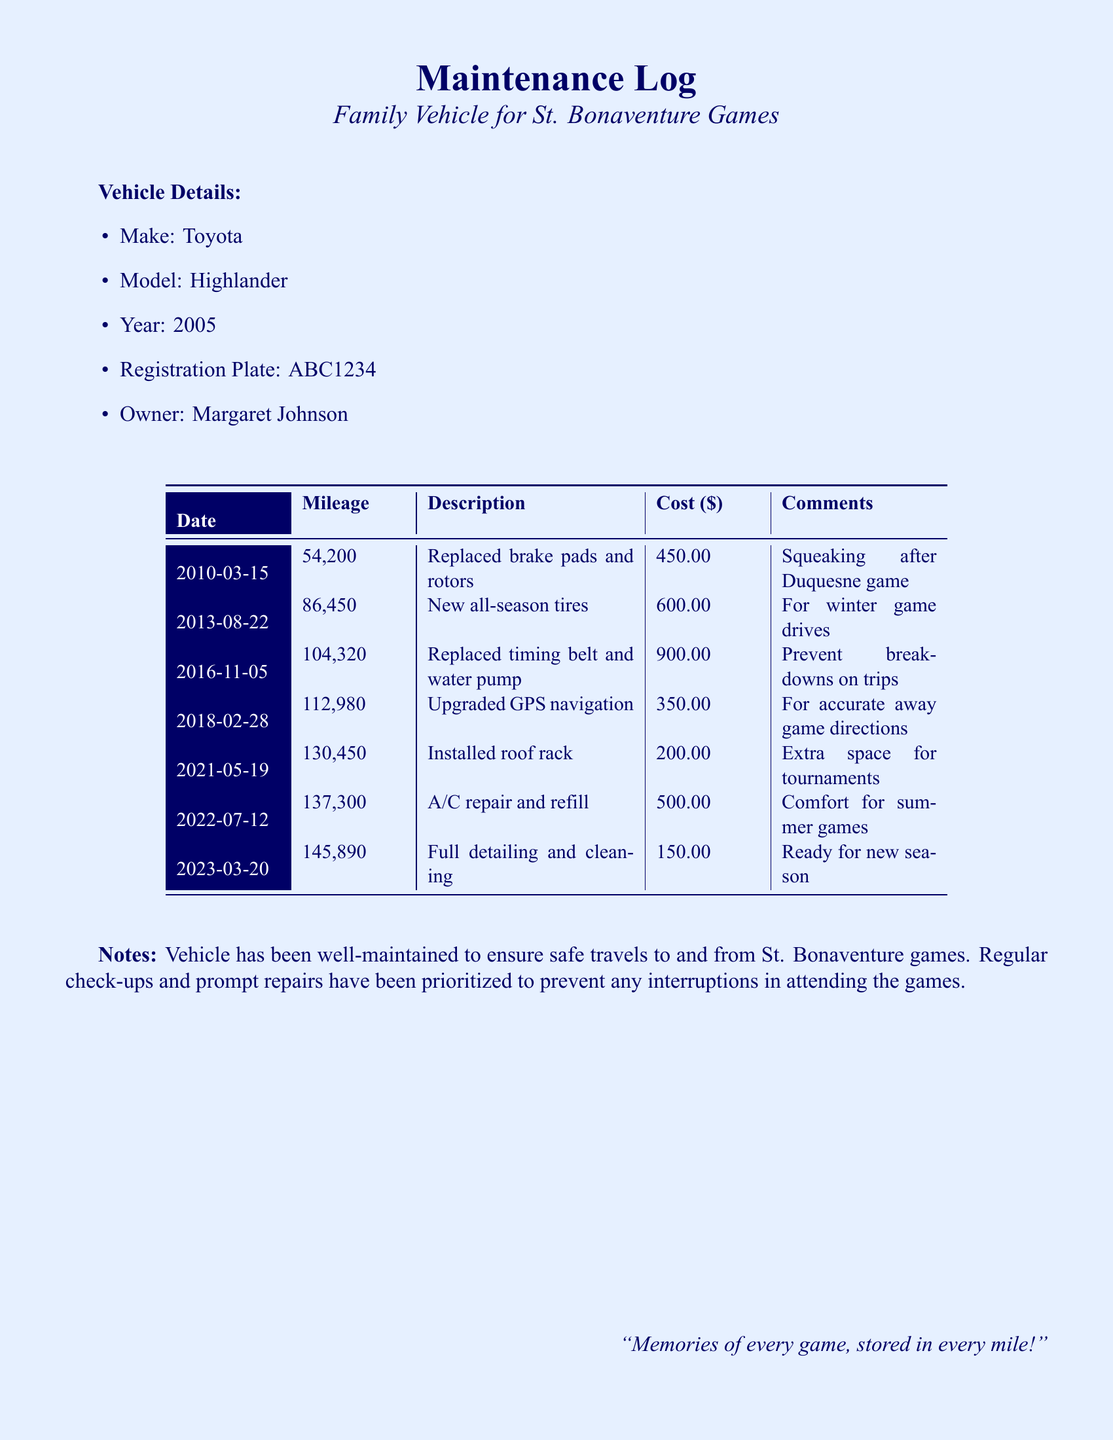What is the make of the vehicle? The make is mentioned in the vehicle details section of the document.
Answer: Toyota What year was the vehicle manufactured? The year of manufacture is explicitly listed in the vehicle details.
Answer: 2005 How much did it cost to replace the brake pads and rotors? The cost is provided alongside the description in the maintenance log.
Answer: 450.00 When was the A/C repair performed? The date for the A/C repair is found in the maintenance log table.
Answer: 2022-07-12 What mileage was recorded when the timing belt and water pump were replaced? The mileage is indicated next to the corresponding maintenance entry.
Answer: 104,320 How much was spent on new all-season tires? The amount spent is listed in the cost column for that service.
Answer: 600.00 What upgrade was made to the vehicle in 2018? The description of the upgrade is provided in the maintenance log under that date.
Answer: Upgraded GPS navigation Why was the roof rack installed? The comment section provides the reason for the installation of the roof rack.
Answer: Extra space for tournaments What does the document reflect about vehicle maintenance? The notes section summarizes the maintenance practices related to the vehicle.
Answer: Well-maintained for safe travels 